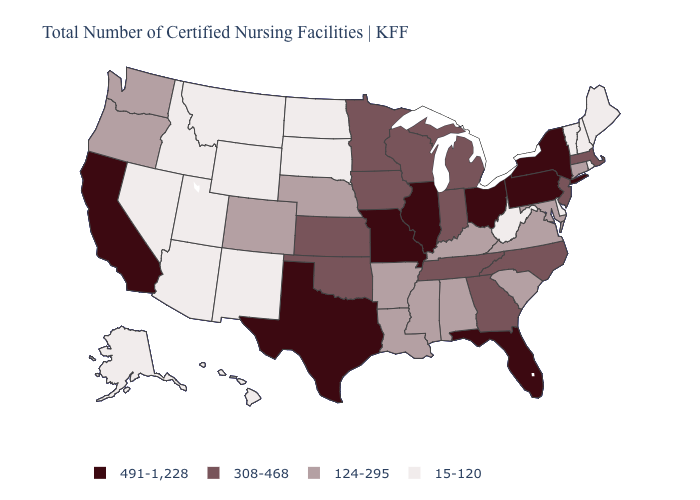What is the value of Arizona?
Keep it brief. 15-120. What is the value of Nevada?
Keep it brief. 15-120. Does the first symbol in the legend represent the smallest category?
Concise answer only. No. Does South Carolina have a higher value than Wisconsin?
Answer briefly. No. Name the states that have a value in the range 124-295?
Answer briefly. Alabama, Arkansas, Colorado, Connecticut, Kentucky, Louisiana, Maryland, Mississippi, Nebraska, Oregon, South Carolina, Virginia, Washington. Is the legend a continuous bar?
Write a very short answer. No. What is the lowest value in states that border Texas?
Short answer required. 15-120. What is the value of Texas?
Write a very short answer. 491-1,228. What is the highest value in the USA?
Be succinct. 491-1,228. Does Kansas have a higher value than Wyoming?
Write a very short answer. Yes. What is the highest value in the MidWest ?
Quick response, please. 491-1,228. Name the states that have a value in the range 15-120?
Be succinct. Alaska, Arizona, Delaware, Hawaii, Idaho, Maine, Montana, Nevada, New Hampshire, New Mexico, North Dakota, Rhode Island, South Dakota, Utah, Vermont, West Virginia, Wyoming. Name the states that have a value in the range 124-295?
Short answer required. Alabama, Arkansas, Colorado, Connecticut, Kentucky, Louisiana, Maryland, Mississippi, Nebraska, Oregon, South Carolina, Virginia, Washington. Is the legend a continuous bar?
Quick response, please. No. Does North Carolina have the same value as Alaska?
Be succinct. No. 